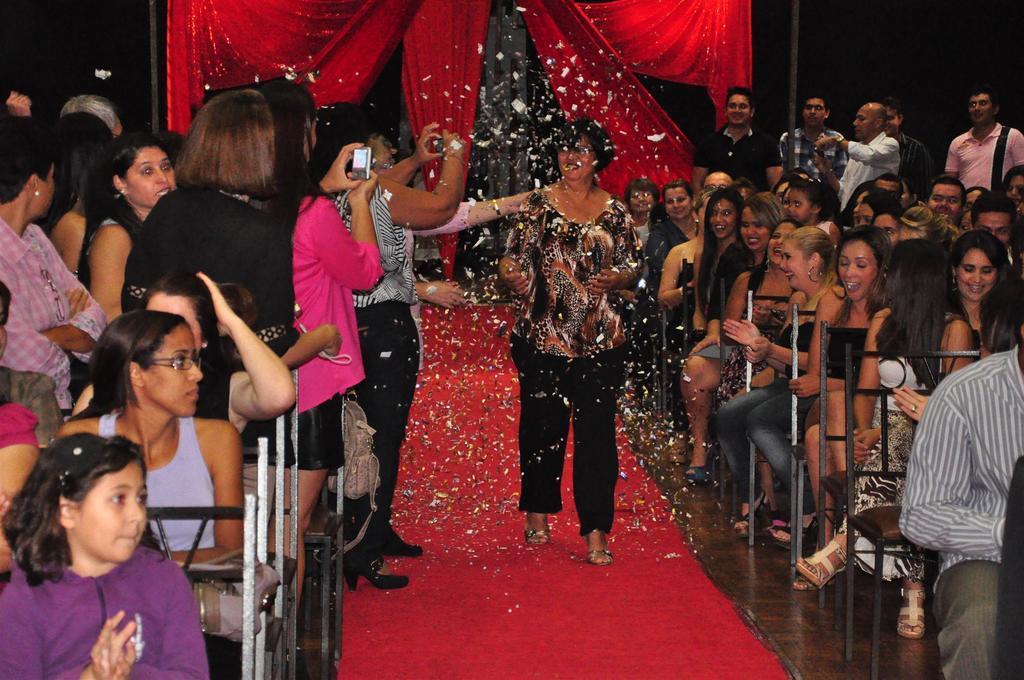How would you summarize this image in a sentence or two? In this image we can see people are sitting on the chairs and there are few people standing on the floor. In the background we can see poles and curtains. 